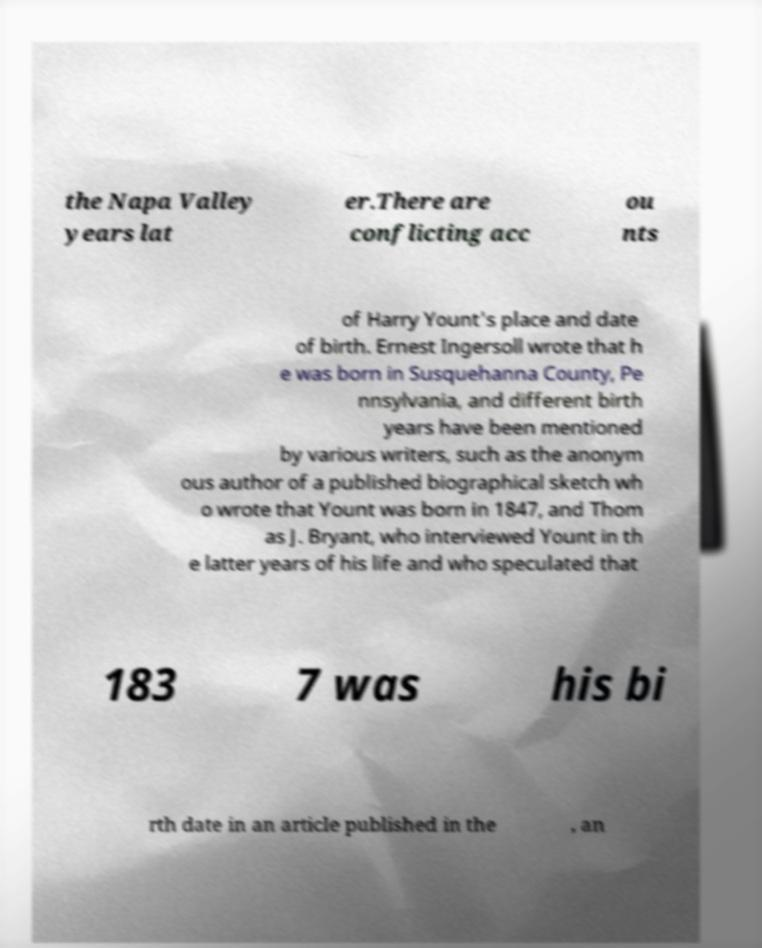There's text embedded in this image that I need extracted. Can you transcribe it verbatim? the Napa Valley years lat er.There are conflicting acc ou nts of Harry Yount's place and date of birth. Ernest Ingersoll wrote that h e was born in Susquehanna County, Pe nnsylvania, and different birth years have been mentioned by various writers, such as the anonym ous author of a published biographical sketch wh o wrote that Yount was born in 1847, and Thom as J. Bryant, who interviewed Yount in th e latter years of his life and who speculated that 183 7 was his bi rth date in an article published in the , an 